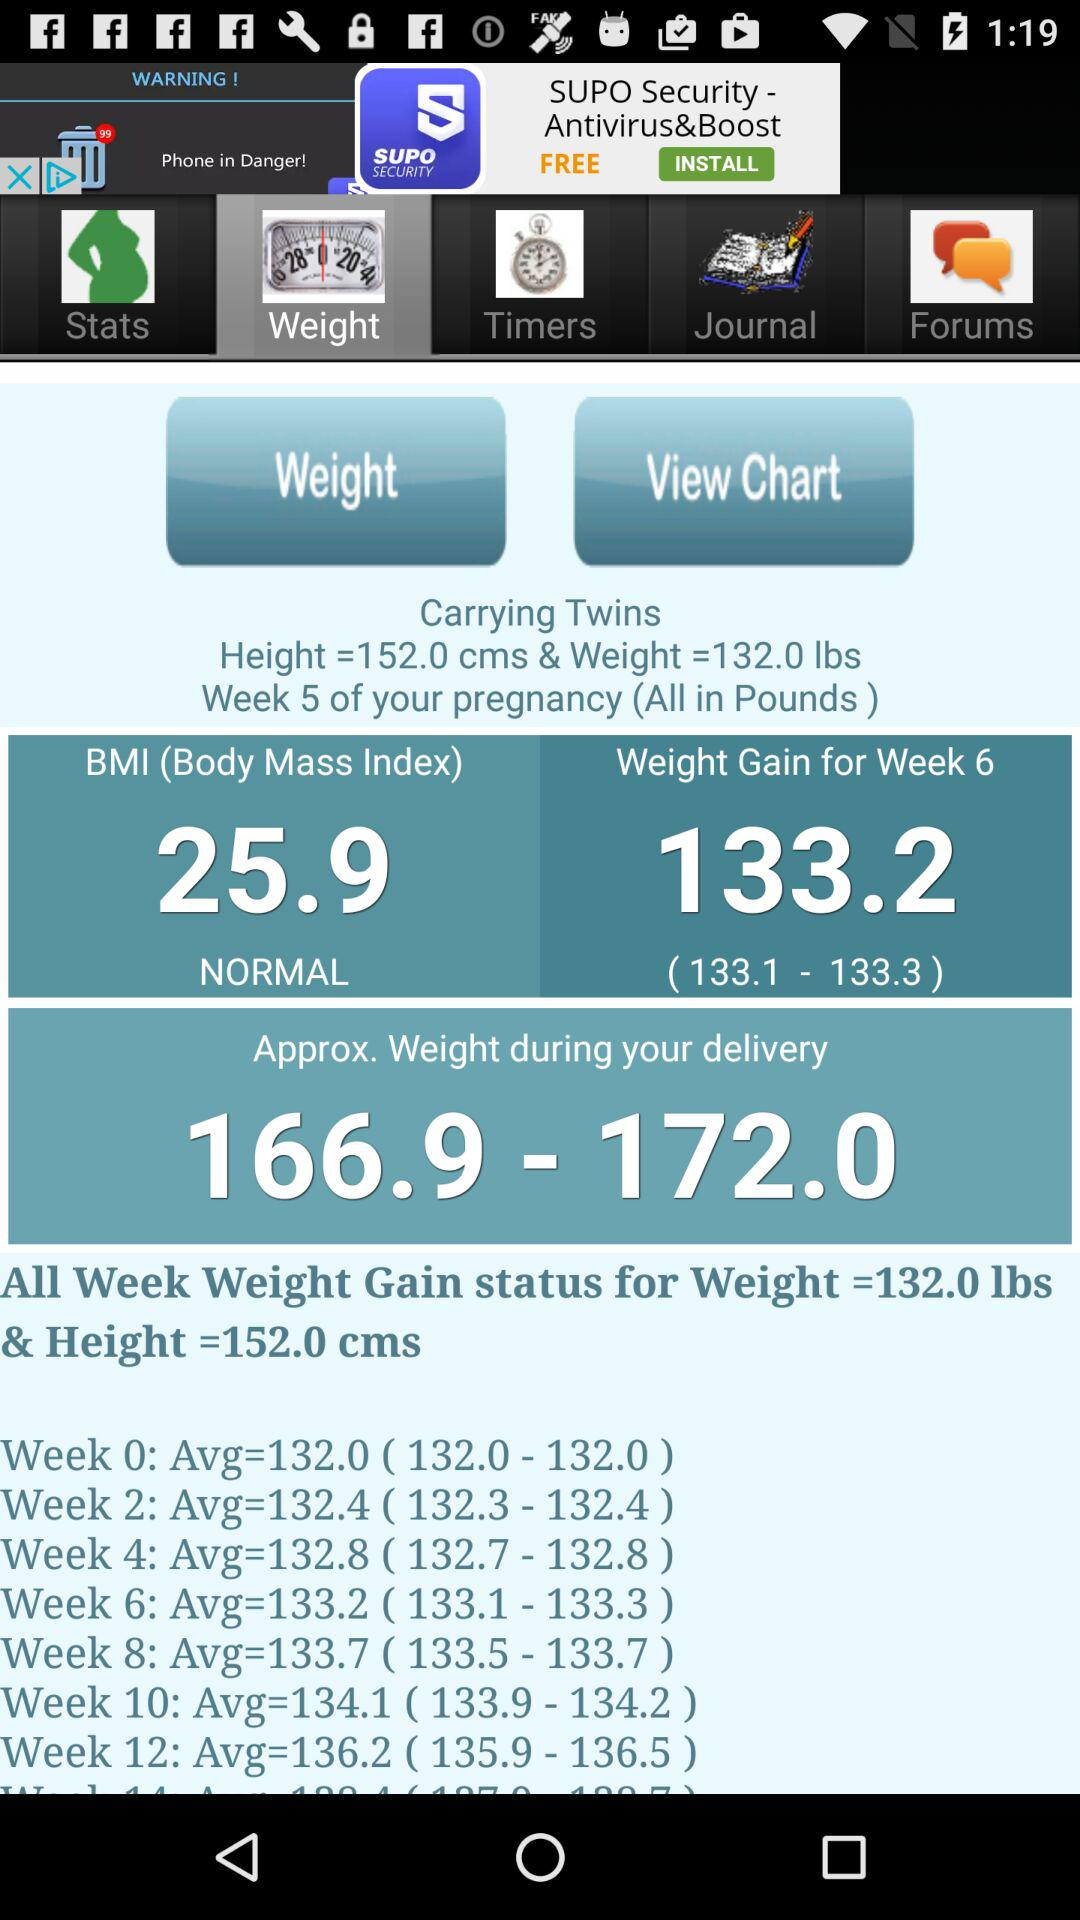What is the normal body mass index? The normal body mass index is 25.9. 